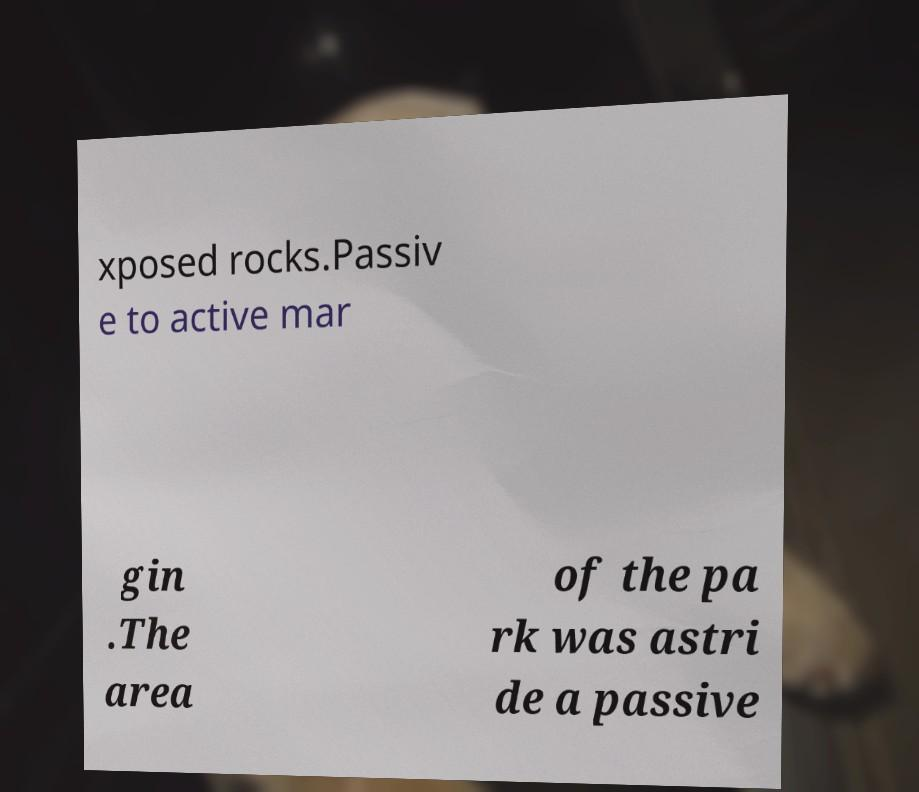For documentation purposes, I need the text within this image transcribed. Could you provide that? xposed rocks.Passiv e to active mar gin .The area of the pa rk was astri de a passive 